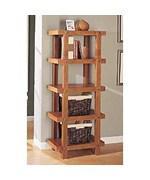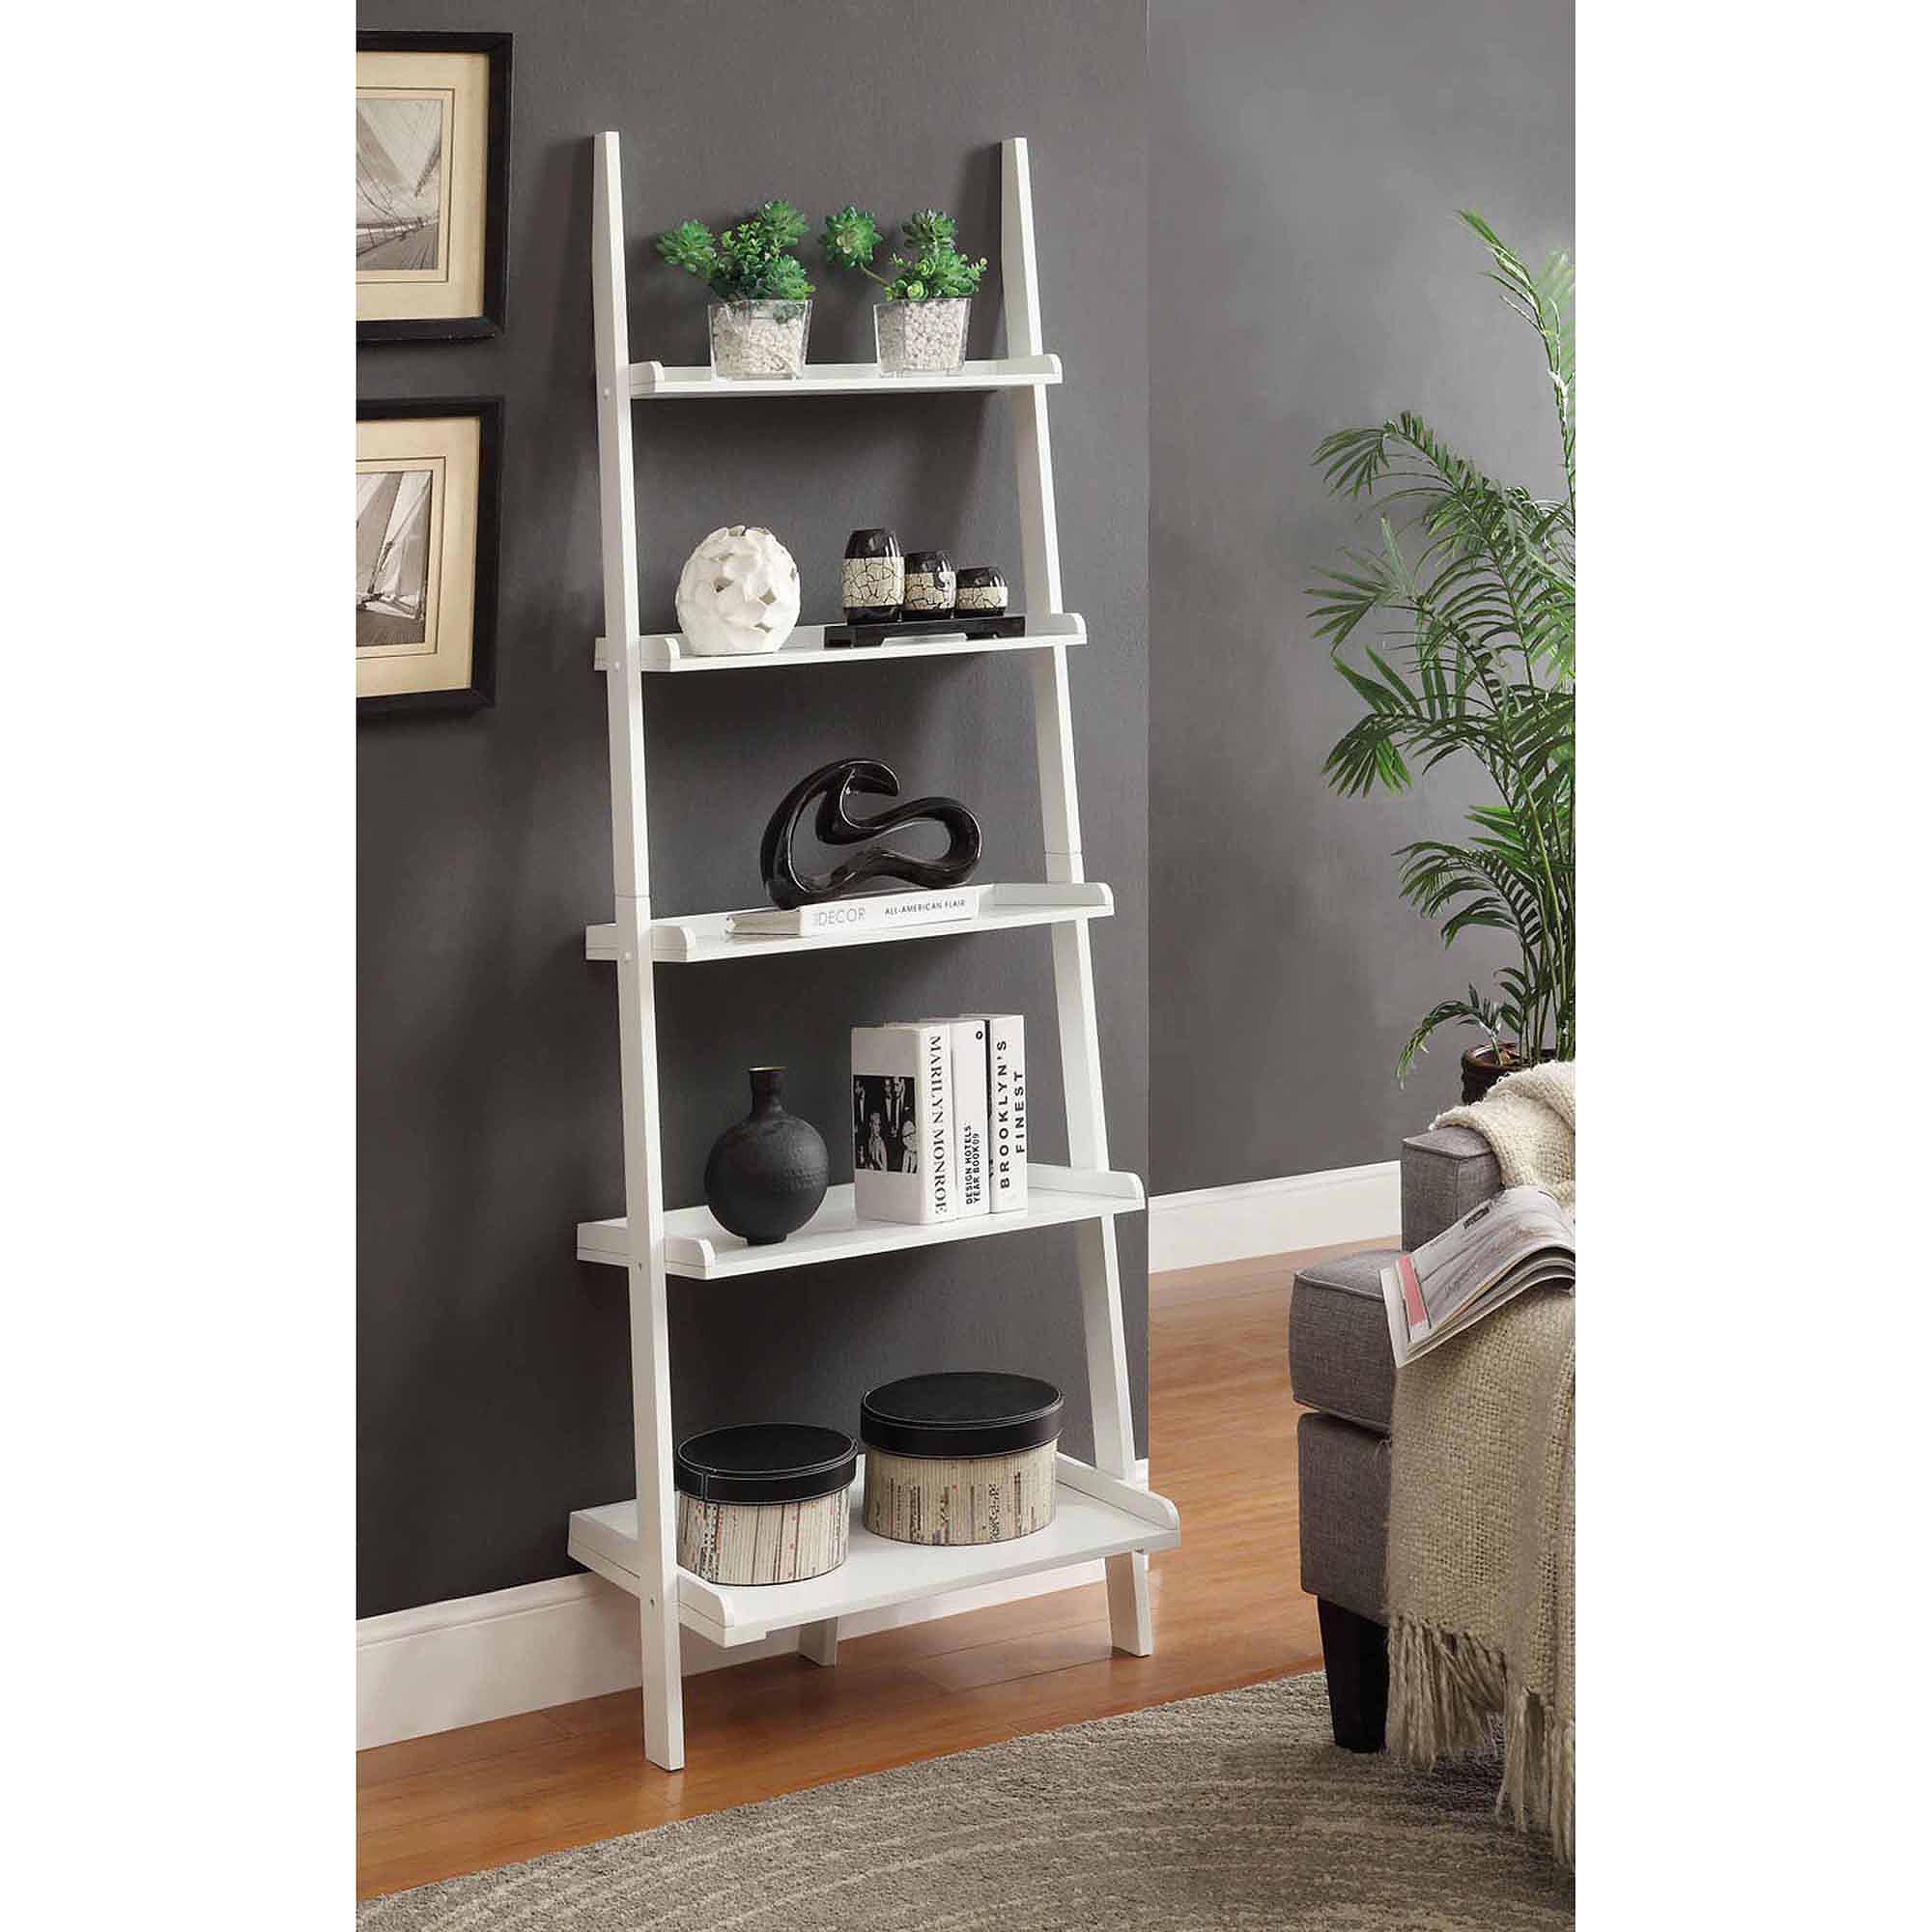The first image is the image on the left, the second image is the image on the right. Considering the images on both sides, is "One of the bookshelves is white." valid? Answer yes or no. Yes. 